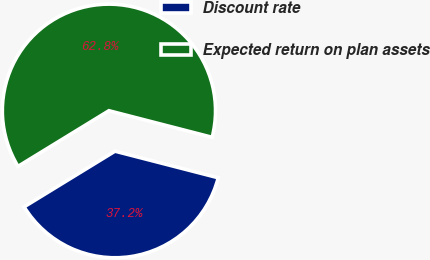Convert chart to OTSL. <chart><loc_0><loc_0><loc_500><loc_500><pie_chart><fcel>Discount rate<fcel>Expected return on plan assets<nl><fcel>37.24%<fcel>62.76%<nl></chart> 